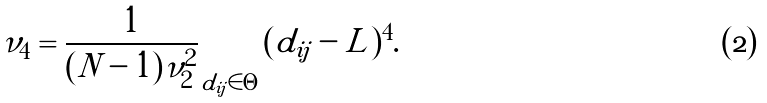Convert formula to latex. <formula><loc_0><loc_0><loc_500><loc_500>\nu _ { 4 } = \frac { 1 } { ( N - 1 ) \nu _ { 2 } ^ { 2 } } \sum _ { d _ { i j } \in \Theta } ( d _ { i j } - L ) ^ { 4 } .</formula> 